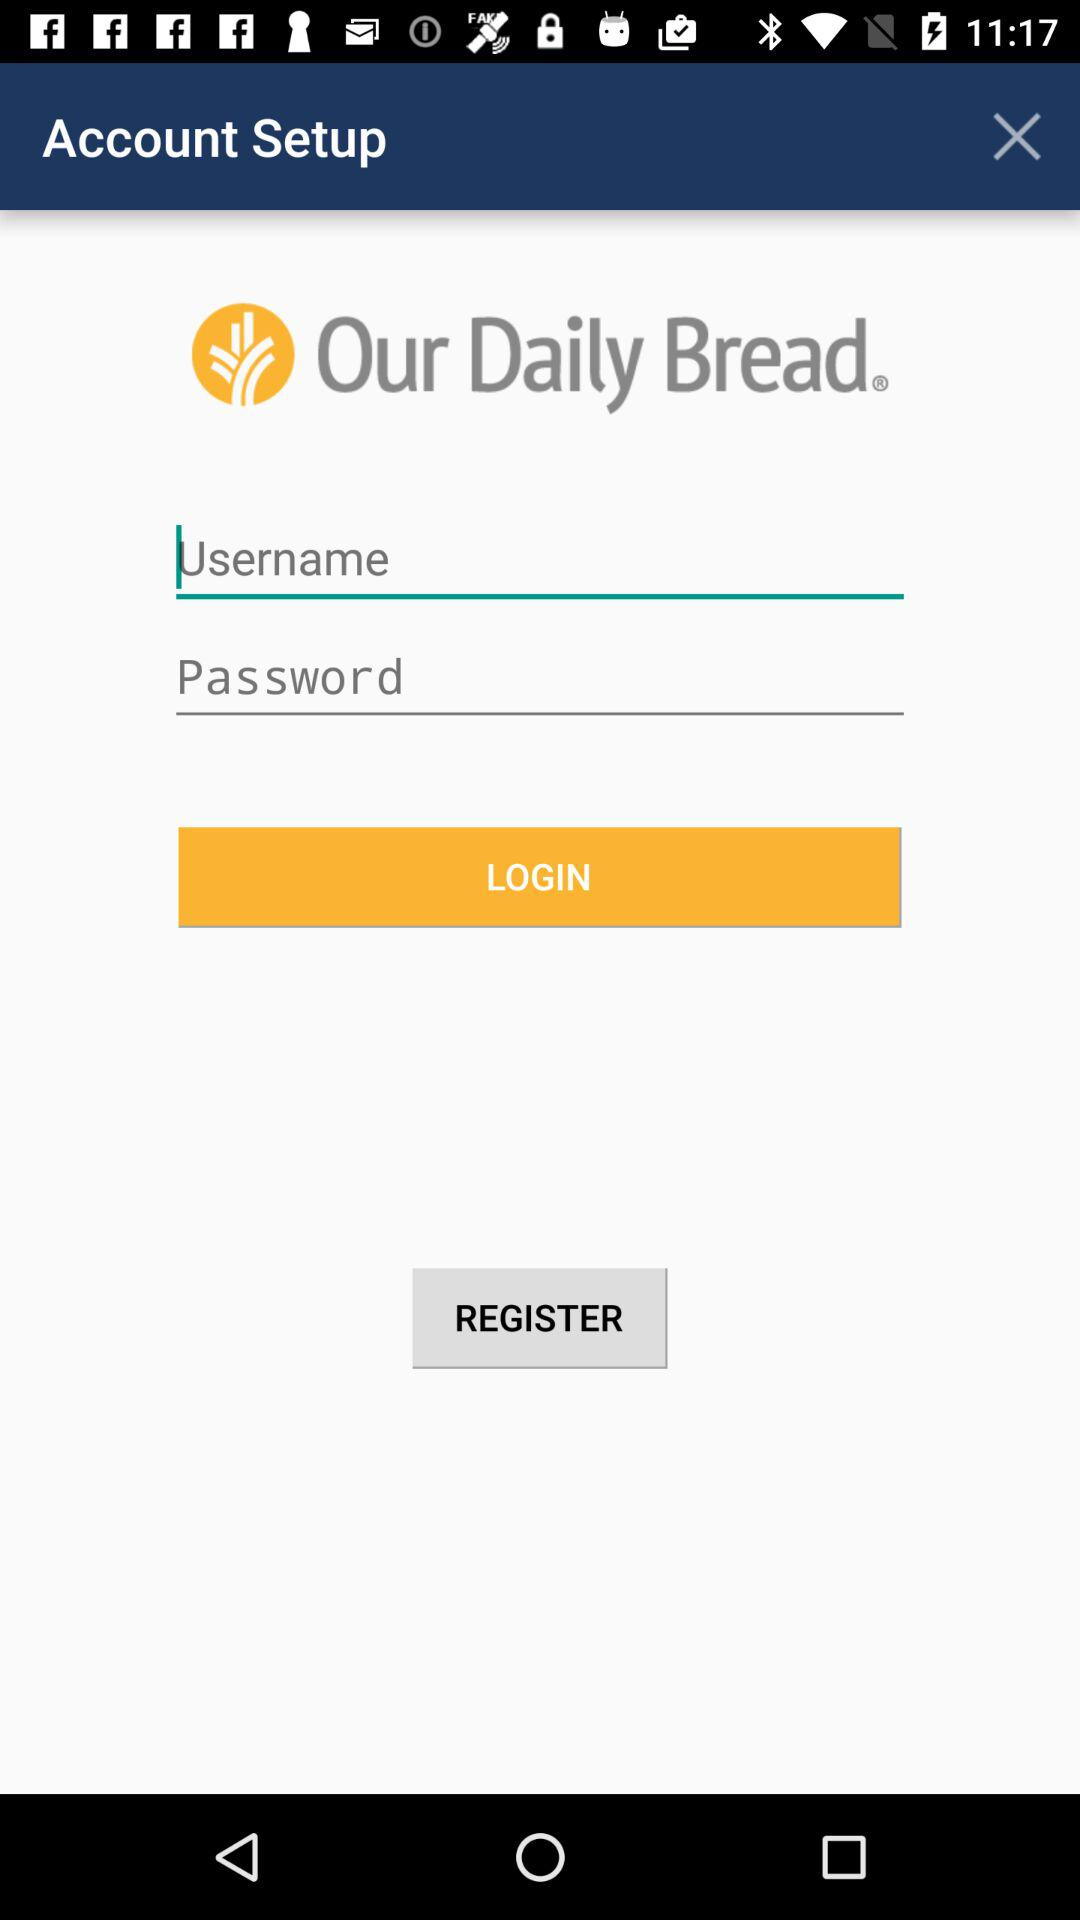What is the name of the application? The name of the application is "Our Daily Bread". 